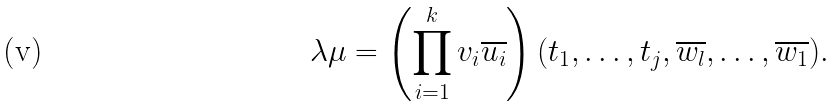<formula> <loc_0><loc_0><loc_500><loc_500>\lambda \mu = \left ( \prod _ { i = 1 } ^ { k } v _ { i } \overline { u _ { i } } \right ) ( t _ { 1 } , \dots , t _ { j } , \overline { w _ { l } } , \dots , \overline { w _ { 1 } } ) .</formula> 